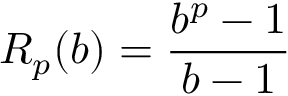<formula> <loc_0><loc_0><loc_500><loc_500>R _ { p } ( b ) = { \frac { b ^ { p } - 1 } { b - 1 } }</formula> 